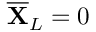<formula> <loc_0><loc_0><loc_500><loc_500>\overline { X } _ { L } = 0</formula> 